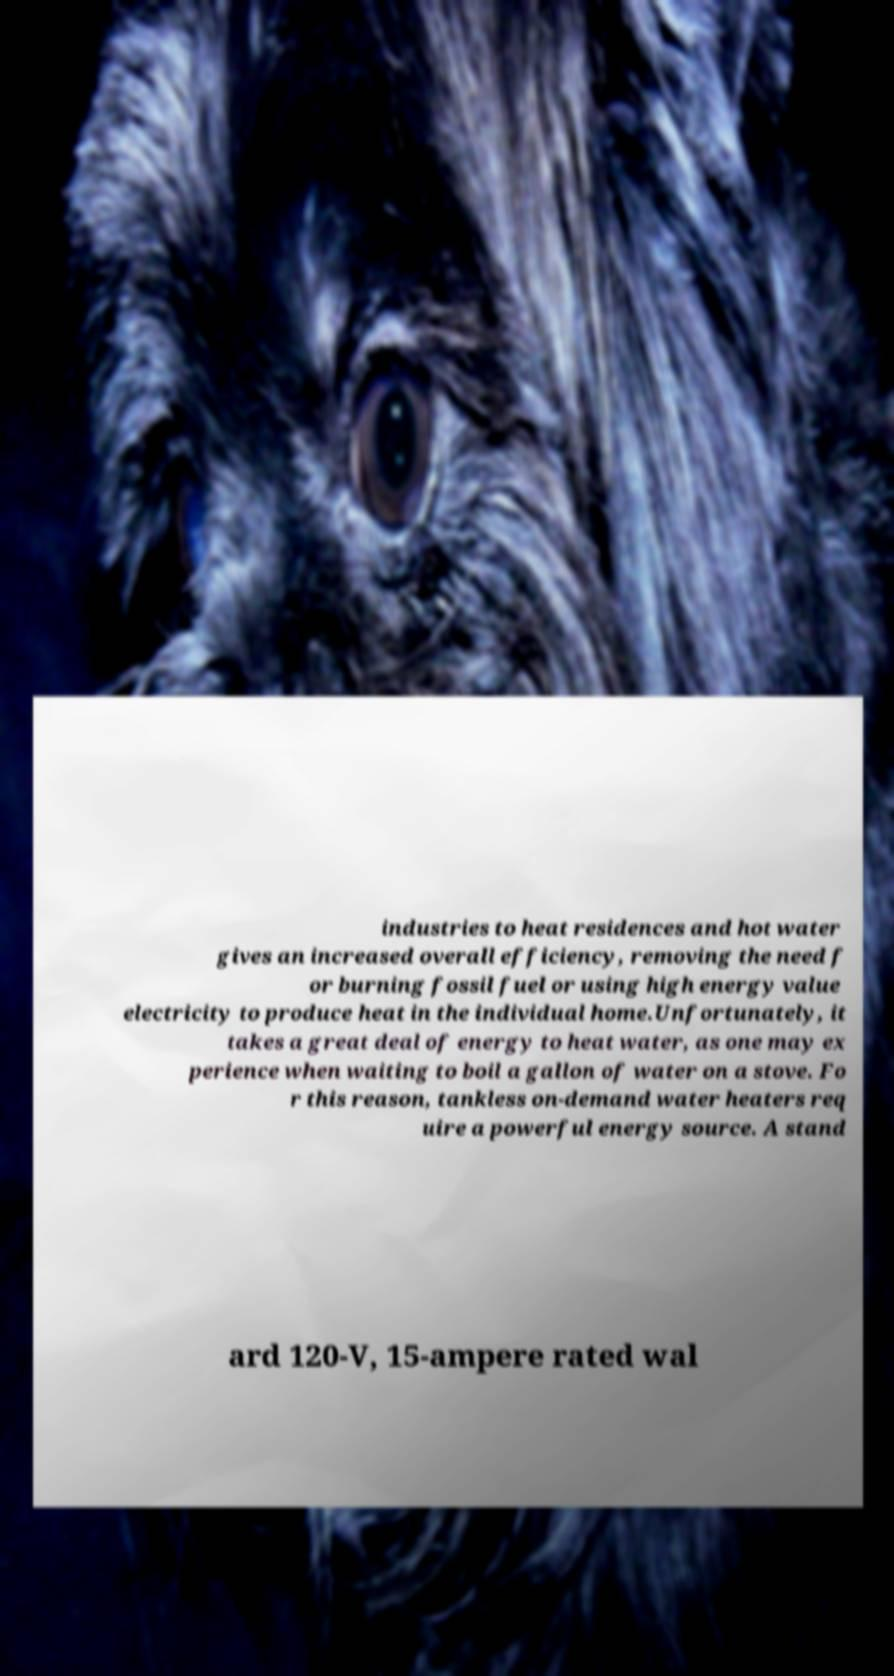I need the written content from this picture converted into text. Can you do that? industries to heat residences and hot water gives an increased overall efficiency, removing the need f or burning fossil fuel or using high energy value electricity to produce heat in the individual home.Unfortunately, it takes a great deal of energy to heat water, as one may ex perience when waiting to boil a gallon of water on a stove. Fo r this reason, tankless on-demand water heaters req uire a powerful energy source. A stand ard 120-V, 15-ampere rated wal 